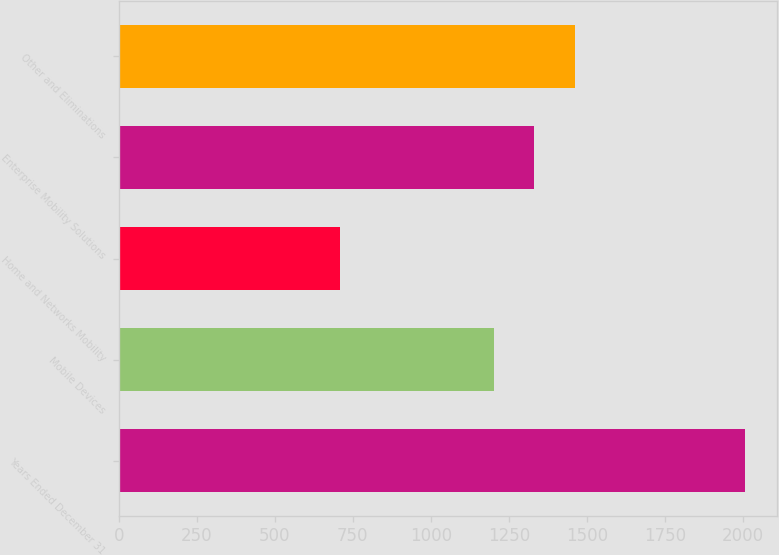<chart> <loc_0><loc_0><loc_500><loc_500><bar_chart><fcel>Years Ended December 31<fcel>Mobile Devices<fcel>Home and Networks Mobility<fcel>Enterprise Mobility Solutions<fcel>Other and Eliminations<nl><fcel>2007<fcel>1201<fcel>709<fcel>1330.8<fcel>1460.6<nl></chart> 